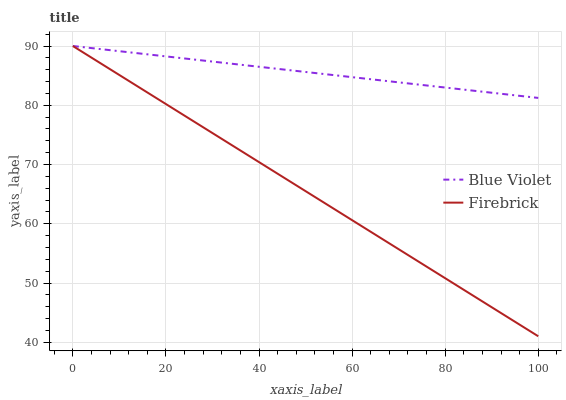Does Firebrick have the minimum area under the curve?
Answer yes or no. Yes. Does Blue Violet have the maximum area under the curve?
Answer yes or no. Yes. Does Blue Violet have the minimum area under the curve?
Answer yes or no. No. Is Blue Violet the smoothest?
Answer yes or no. Yes. Is Firebrick the roughest?
Answer yes or no. Yes. Is Blue Violet the roughest?
Answer yes or no. No. Does Blue Violet have the lowest value?
Answer yes or no. No. 